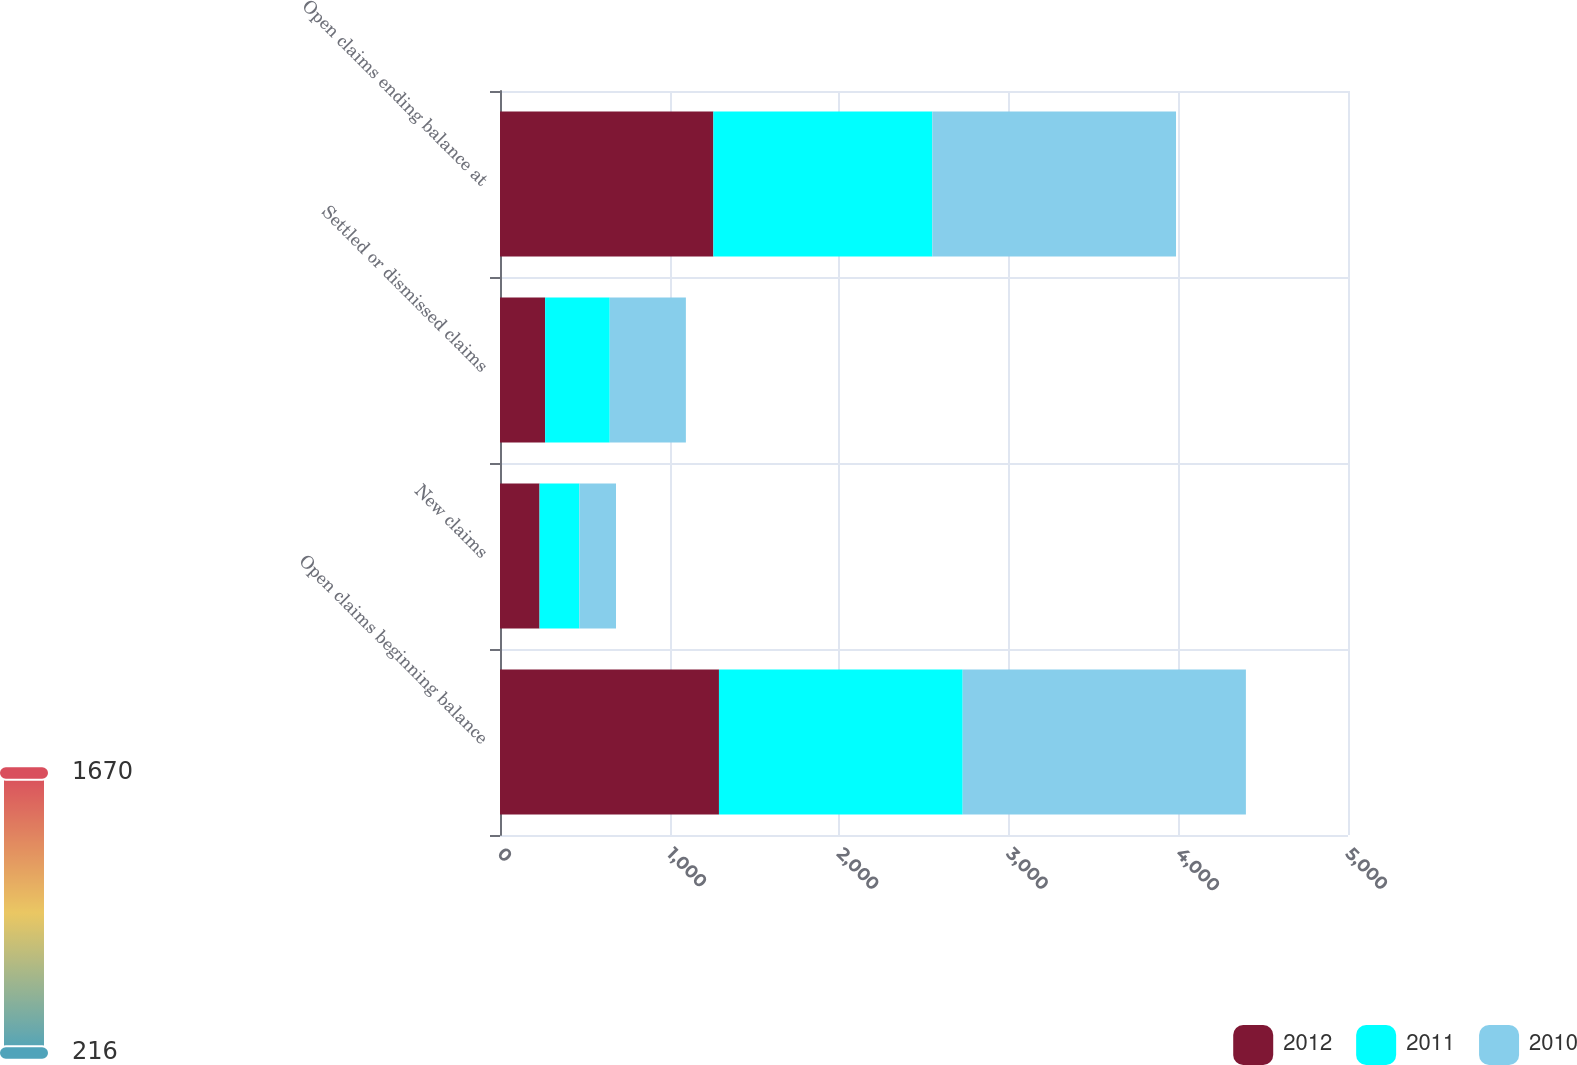Convert chart to OTSL. <chart><loc_0><loc_0><loc_500><loc_500><stacked_bar_chart><ecel><fcel>Open claims beginning balance<fcel>New claims<fcel>Settled or dismissed claims<fcel>Open claims ending balance at<nl><fcel>2012<fcel>1291<fcel>233<fcel>266<fcel>1258<nl><fcel>2011<fcel>1437<fcel>235<fcel>381<fcel>1291<nl><fcel>2010<fcel>1670<fcel>216<fcel>449<fcel>1437<nl></chart> 